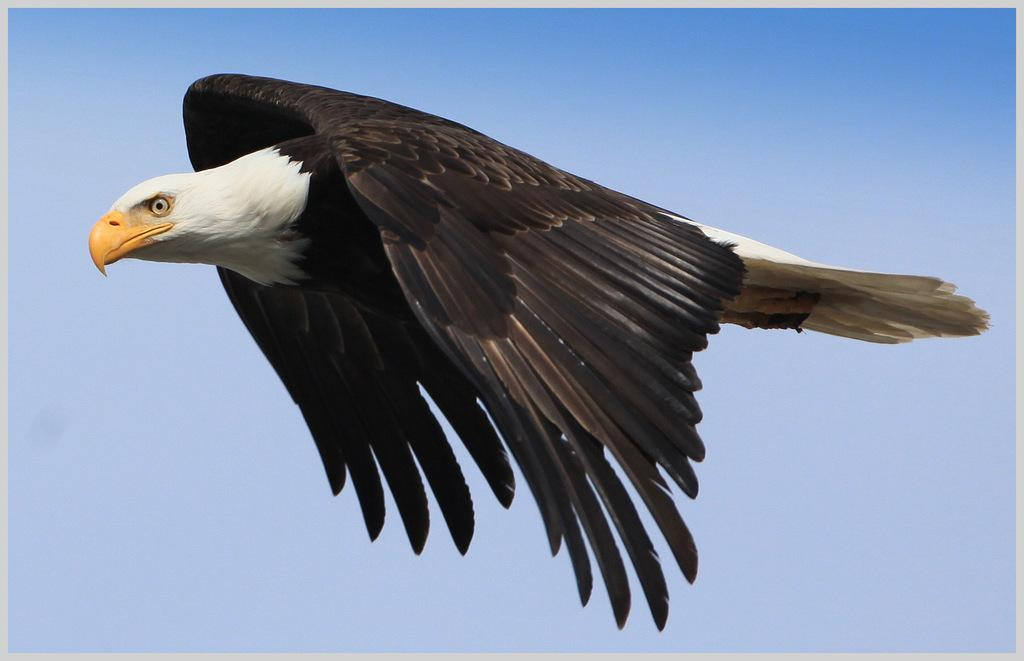What animal is the main subject of the picture? There is an eagle in the picture. What is the eagle doing in the image? The eagle is flying in the sky. What can be seen in the sky besides the eagle? There are clouds in the sky. Can you tell me how many goldfish are swimming in the sky in the image? There are no goldfish present in the image; it features an eagle flying in the sky. What type of discovery was made by the eagle in the image? There is no indication of a discovery in the image; it simply shows an eagle flying in the sky. 